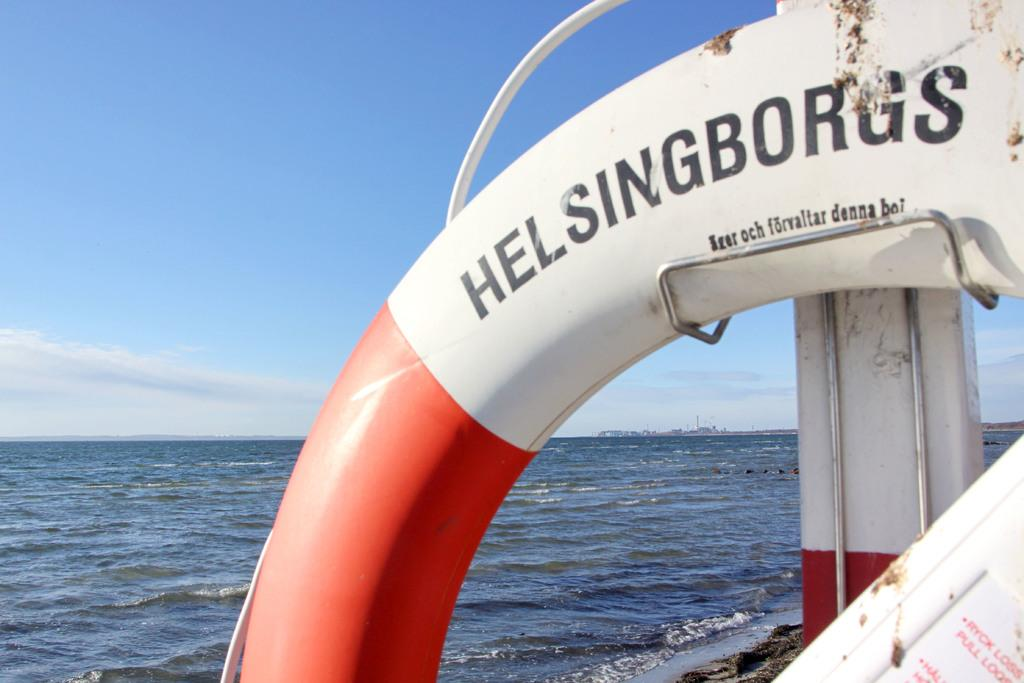Provide a one-sentence caption for the provided image. Black Helsingborgs sign on a boat in the water. 